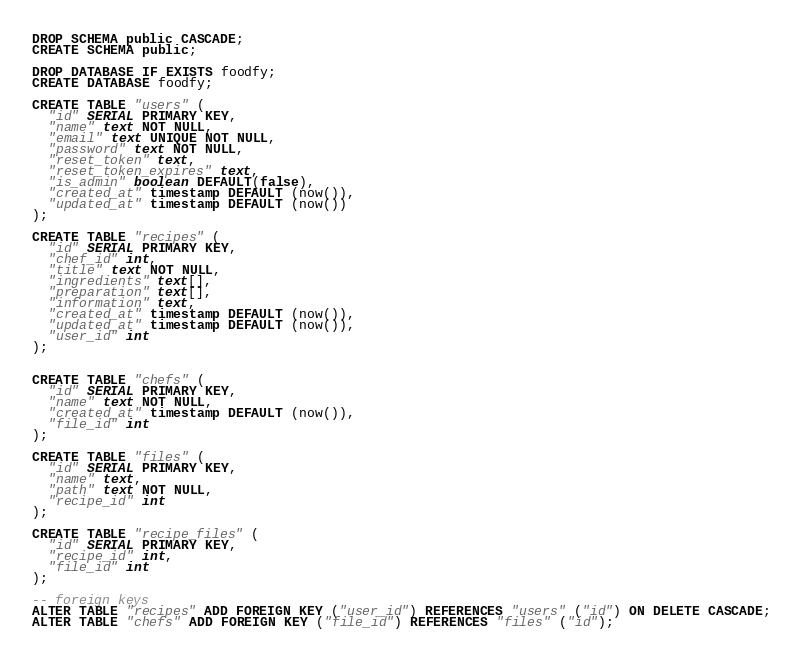Convert code to text. <code><loc_0><loc_0><loc_500><loc_500><_SQL_>DROP SCHEMA public CASCADE;
CREATE SCHEMA public;

DROP DATABASE IF EXISTS foodfy;
CREATE DATABASE foodfy;

CREATE TABLE "users" (
  "id" SERIAL PRIMARY KEY,
  "name" text NOT NULL,
  "email" text UNIQUE NOT NULL,
  "password" text NOT NULL,
  "reset_token" text,
  "reset_token_expires" text,
  "is_admin" boolean DEFAULT(false),
  "created_at" timestamp DEFAULT (now()),
  "updated_at" timestamp DEFAULT (now())
);

CREATE TABLE "recipes" (
  "id" SERIAL PRIMARY KEY,
  "chef_id" int,
  "title" text NOT NULL,
  "ingredients" text[],
  "preparation" text[],
  "information" text,
  "created_at" timestamp DEFAULT (now()),
  "updated_at" timestamp DEFAULT (now()),
  "user_id" int
);


CREATE TABLE "chefs" (
  "id" SERIAL PRIMARY KEY,
  "name" text NOT NULL,
  "created_at" timestamp DEFAULT (now()),
  "file_id" int
);

CREATE TABLE "files" (
  "id" SERIAL PRIMARY KEY,
  "name" text,
  "path" text NOT NULL,
  "recipe_id" int
);

CREATE TABLE "recipe_files" (
  "id" SERIAL PRIMARY KEY,
  "recipe_id" int,
  "file_id" int
);

-- foreign keys
ALTER TABLE "recipes" ADD FOREIGN KEY ("user_id") REFERENCES "users" ("id") ON DELETE CASCADE;
ALTER TABLE "chefs" ADD FOREIGN KEY ("file_id") REFERENCES "files" ("id");</code> 